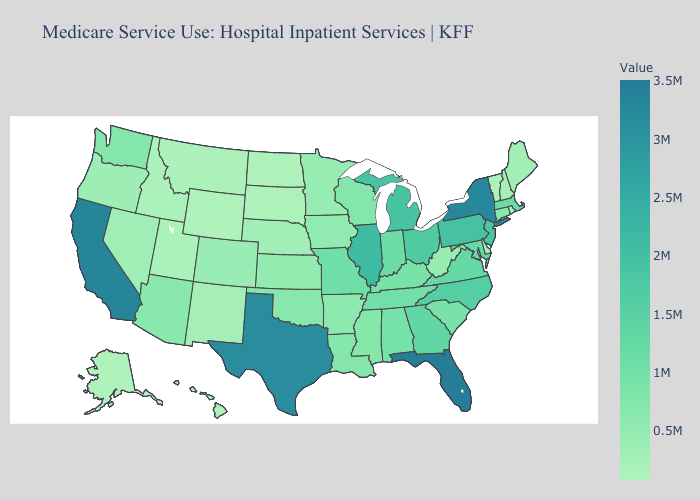Among the states that border Texas , which have the lowest value?
Quick response, please. New Mexico. Is the legend a continuous bar?
Quick response, please. Yes. Does Alaska have the lowest value in the USA?
Concise answer only. Yes. 